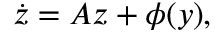<formula> <loc_0><loc_0><loc_500><loc_500>{ \dot { z } } = A z + \phi ( y ) ,</formula> 